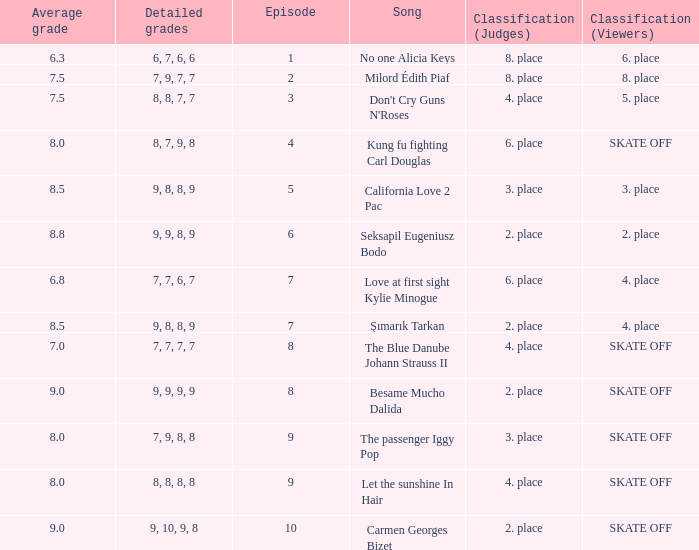Name the classification for 9, 9, 8, 9 2. place. 